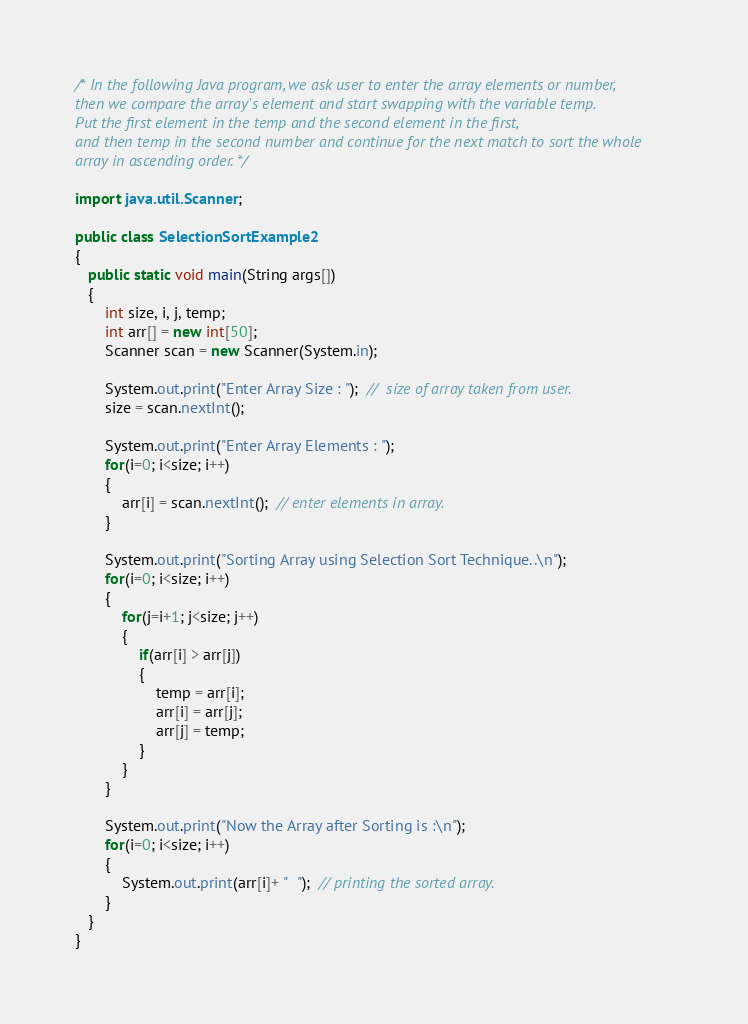Convert code to text. <code><loc_0><loc_0><loc_500><loc_500><_Java_>/* In the following Java program, we ask user to enter the array elements or number, 
then we compare the array's element and start swapping with the variable temp. 
Put the first element in the temp and the second element in the first, 
and then temp in the second number and continue for the next match to sort the whole
array in ascending order. */

import java.util.Scanner;  
  
public class SelectionSortExample2  
{  
   public static void main(String args[])  
   {  
       int size, i, j, temp;  
       int arr[] = new int[50];  
       Scanner scan = new Scanner(System.in);  
         
       System.out.print("Enter Array Size : ");  //  size of array taken from user.
       size = scan.nextInt();  
         
       System.out.print("Enter Array Elements : ");  
       for(i=0; i<size; i++)  
       {  
           arr[i] = scan.nextInt();  // enter elements in array.
       }  
         
       System.out.print("Sorting Array using Selection Sort Technique..\n");  
       for(i=0; i<size; i++)  
       {  
           for(j=i+1; j<size; j++)  
           {  
               if(arr[i] > arr[j])  
               {  
                   temp = arr[i];  
                   arr[i] = arr[j];  
                   arr[j] = temp;  
               }  
           }  
       }  
         
       System.out.print("Now the Array after Sorting is :\n");  
       for(i=0; i<size; i++)  
       {  
           System.out.print(arr[i]+ "  ");  // printing the sorted array.
       }  
   }  
}  
</code> 